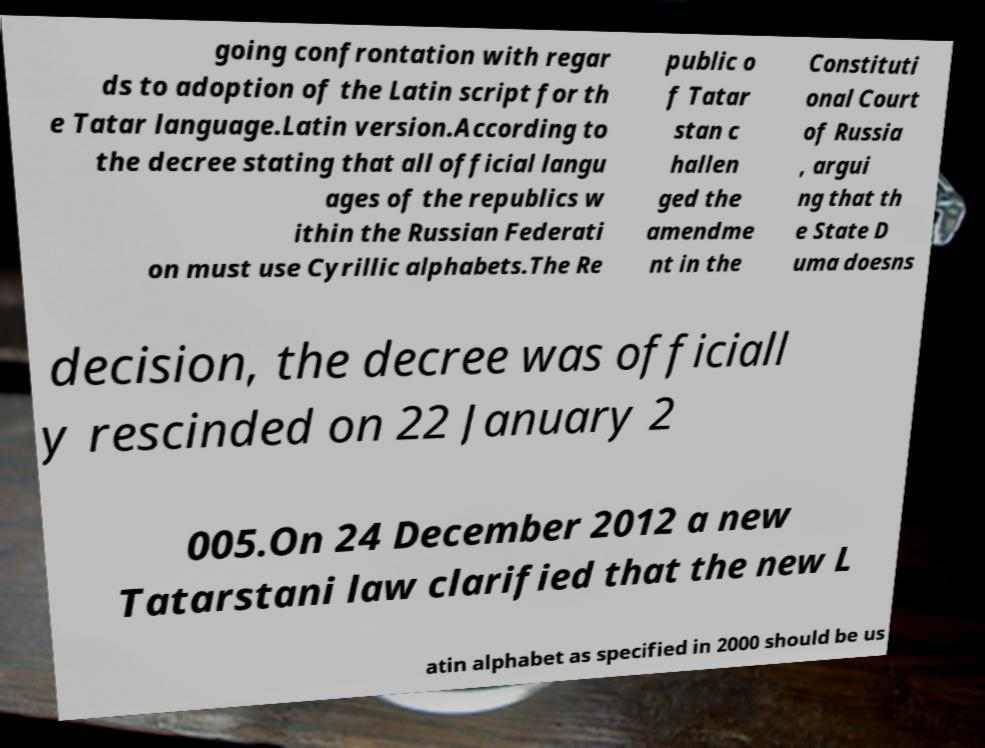Could you extract and type out the text from this image? going confrontation with regar ds to adoption of the Latin script for th e Tatar language.Latin version.According to the decree stating that all official langu ages of the republics w ithin the Russian Federati on must use Cyrillic alphabets.The Re public o f Tatar stan c hallen ged the amendme nt in the Constituti onal Court of Russia , argui ng that th e State D uma doesns decision, the decree was officiall y rescinded on 22 January 2 005.On 24 December 2012 a new Tatarstani law clarified that the new L atin alphabet as specified in 2000 should be us 